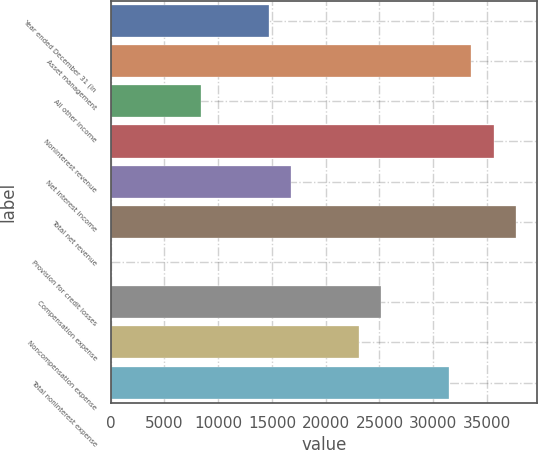Convert chart to OTSL. <chart><loc_0><loc_0><loc_500><loc_500><bar_chart><fcel>Year ended December 31 (in<fcel>Asset management<fcel>All other income<fcel>Noninterest revenue<fcel>Net interest income<fcel>Total net revenue<fcel>Provision for credit losses<fcel>Compensation expense<fcel>Noncompensation expense<fcel>Total noninterest expense<nl><fcel>14683.7<fcel>33557.6<fcel>8392.4<fcel>35654.7<fcel>16780.8<fcel>37751.8<fcel>4<fcel>25169.2<fcel>23072.1<fcel>31460.5<nl></chart> 